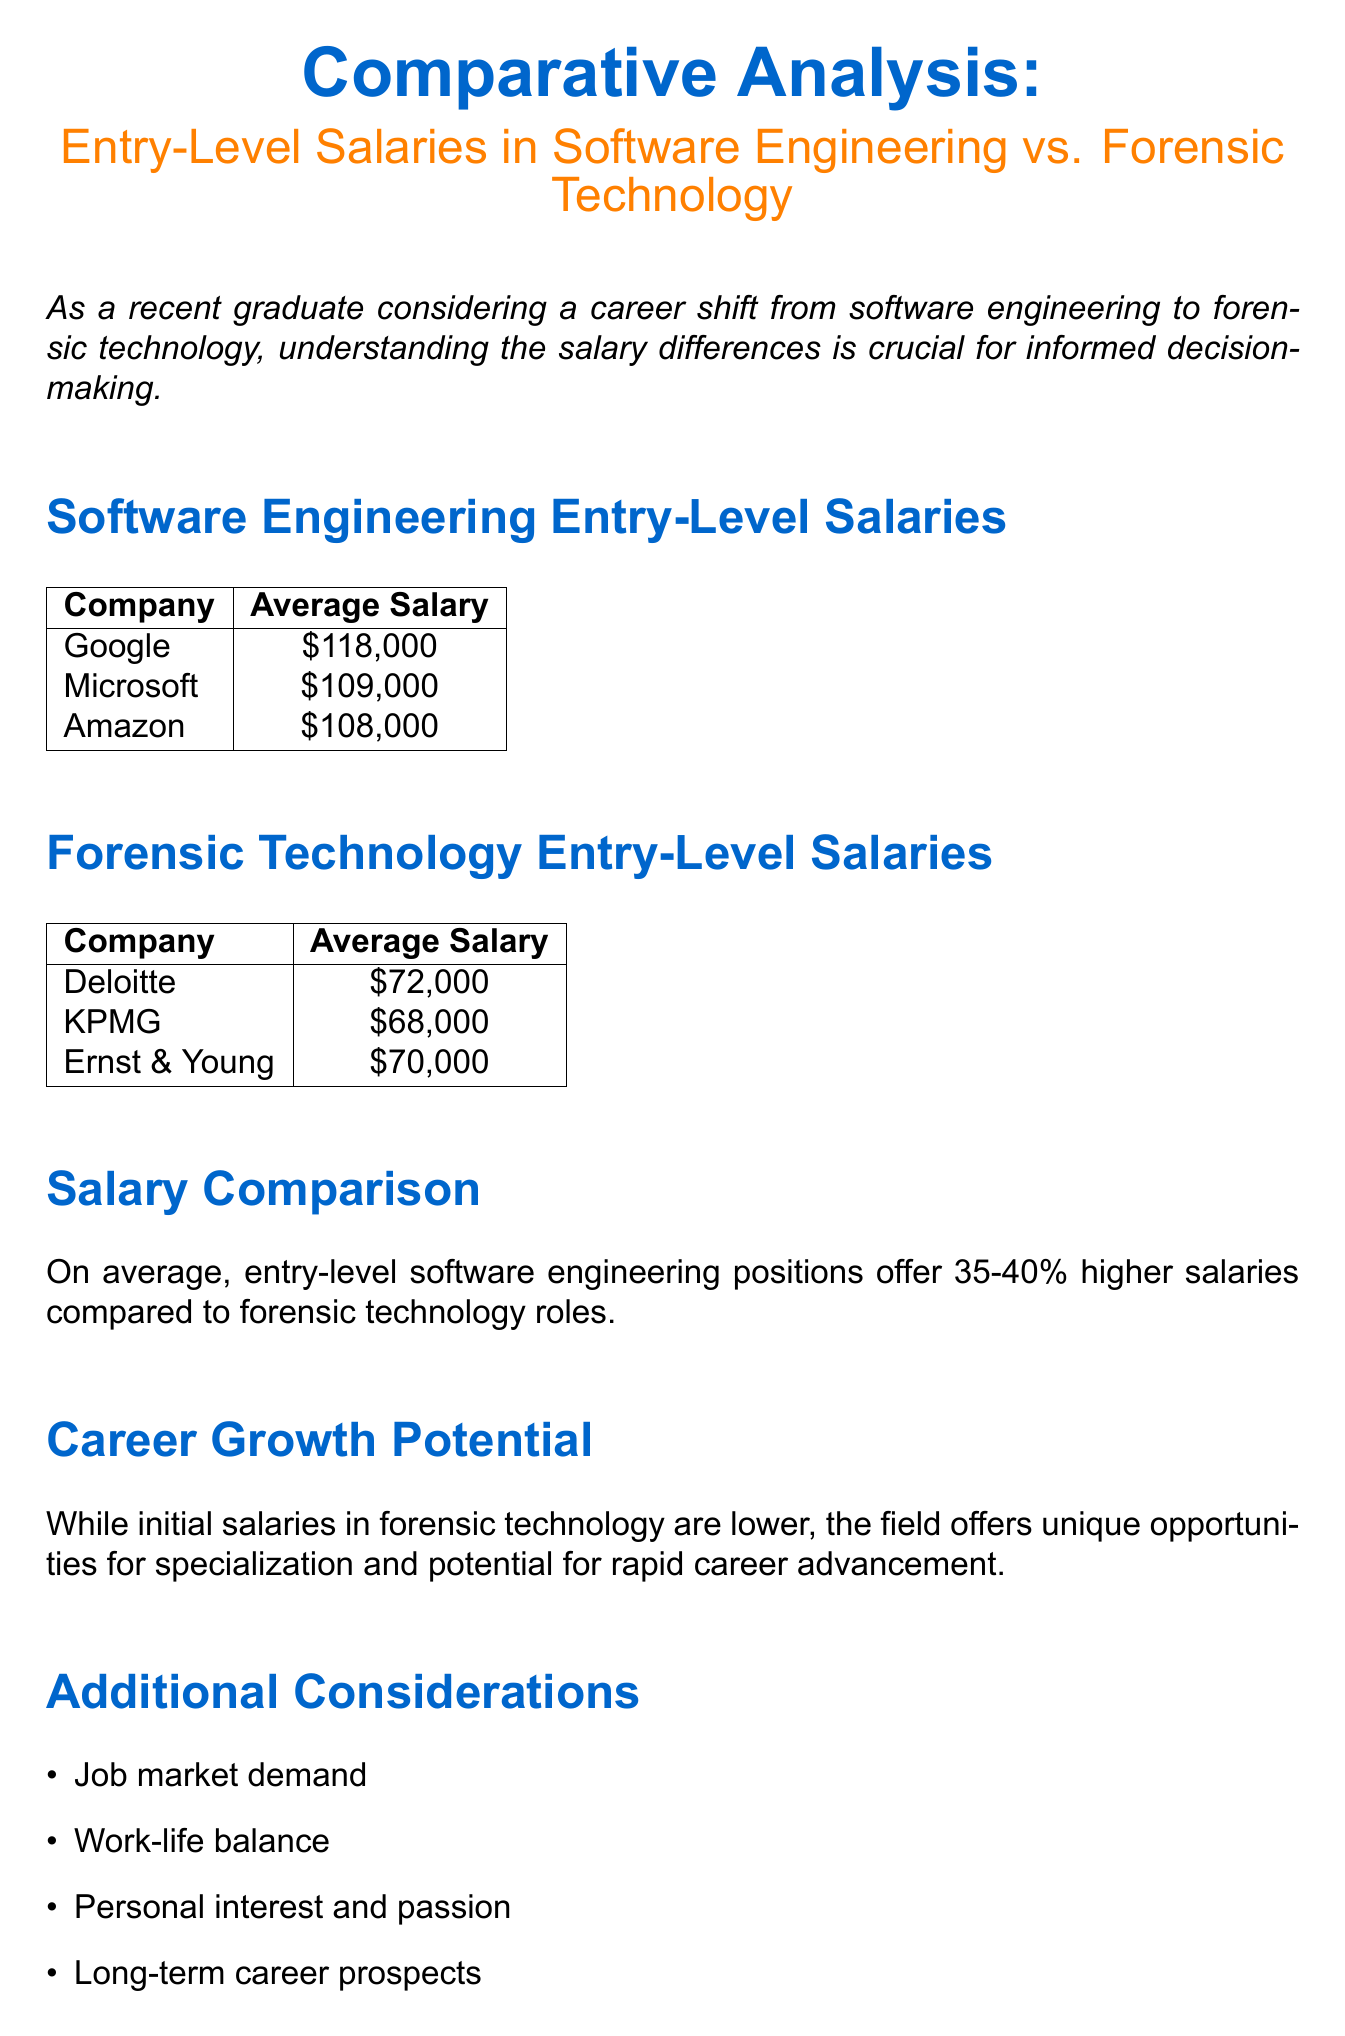What is the average salary at Google? The average salary at Google is mentioned in the document under "Software Engineering Entry-Level Salaries" section.
Answer: $118,000 What is the average salary at KPMG? The average salary at KPMG is found in the "Forensic Technology Entry-Level Salaries" section of the document.
Answer: $68,000 What percentage higher are software engineering salaries compared to forensic technology roles? The document states the average percentage difference mentioned in the "Salary Comparison" section.
Answer: 35-40% What type of roles does the document compare? The document explicitly states the roles it is comparing in the title and introduction.
Answer: Software engineering vs. forensic technology What is one of the additional considerations mentioned? The document lists several points under "Additional Considerations," where one can be cited as an example.
Answer: Job market demand What is the main focus of the document? The purpose of the document is outlined in the introduction.
Answer: Comparative analysis of salaries What is one opportunity offered by forensic technology according to the document? The document highlights aspects of the forensic technology field in the "Career Growth Potential" section.
Answer: Specialization 